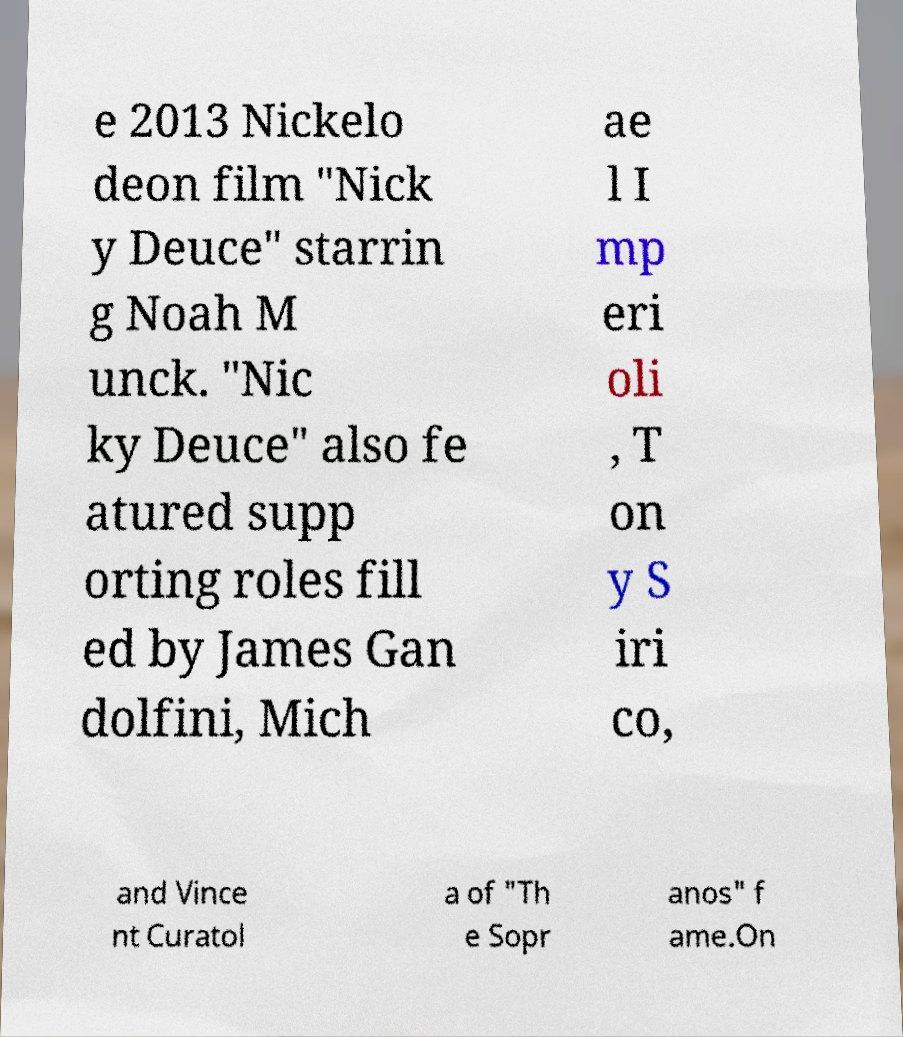What messages or text are displayed in this image? I need them in a readable, typed format. e 2013 Nickelo deon film "Nick y Deuce" starrin g Noah M unck. "Nic ky Deuce" also fe atured supp orting roles fill ed by James Gan dolfini, Mich ae l I mp eri oli , T on y S iri co, and Vince nt Curatol a of "Th e Sopr anos" f ame.On 